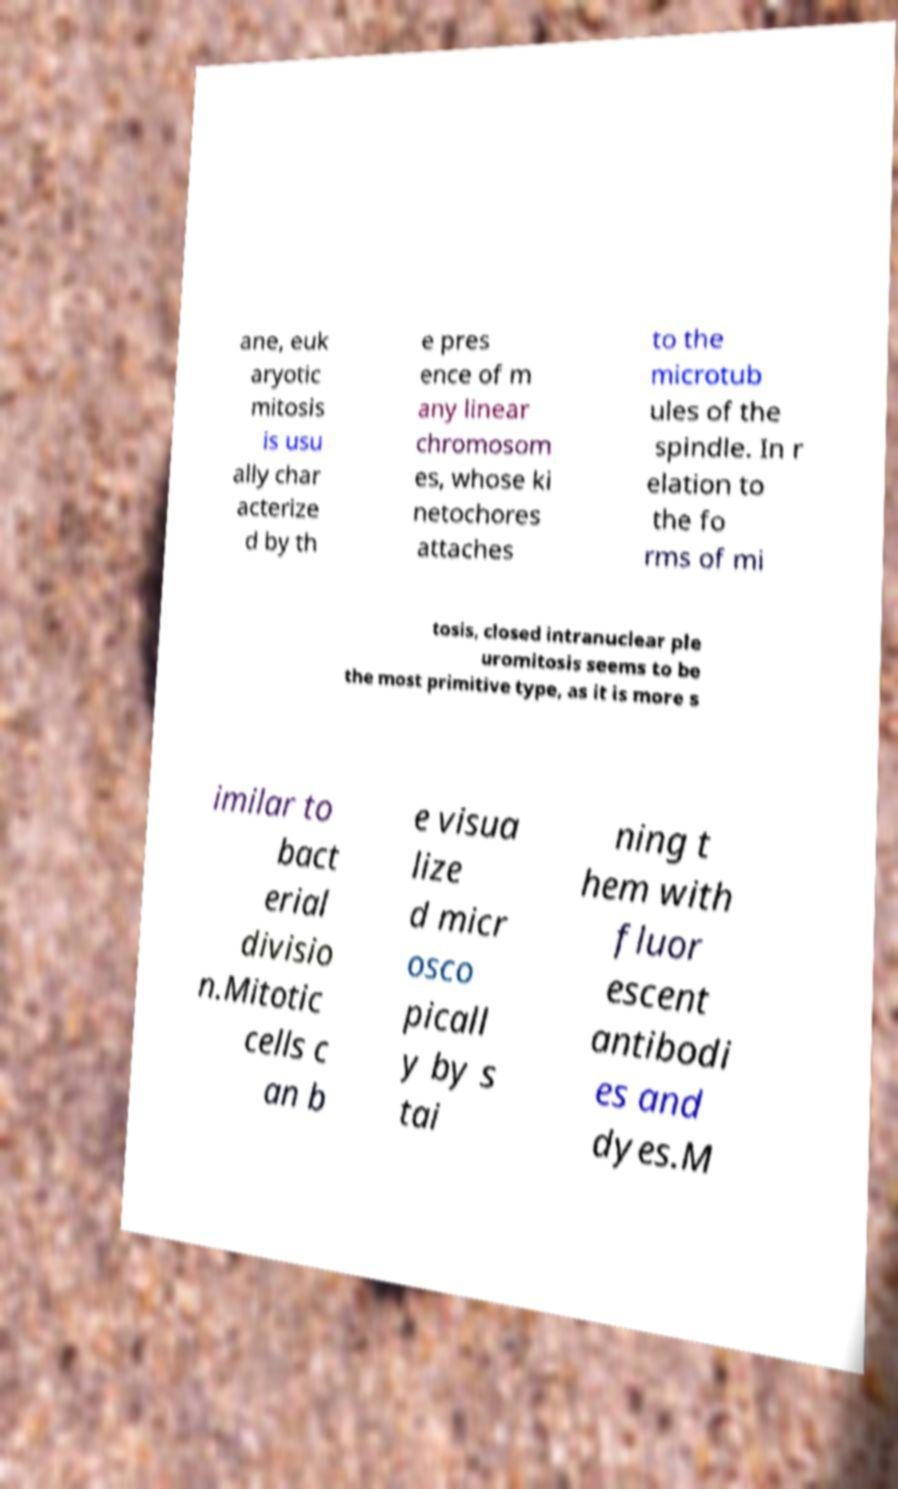Please read and relay the text visible in this image. What does it say? ane, euk aryotic mitosis is usu ally char acterize d by th e pres ence of m any linear chromosom es, whose ki netochores attaches to the microtub ules of the spindle. In r elation to the fo rms of mi tosis, closed intranuclear ple uromitosis seems to be the most primitive type, as it is more s imilar to bact erial divisio n.Mitotic cells c an b e visua lize d micr osco picall y by s tai ning t hem with fluor escent antibodi es and dyes.M 